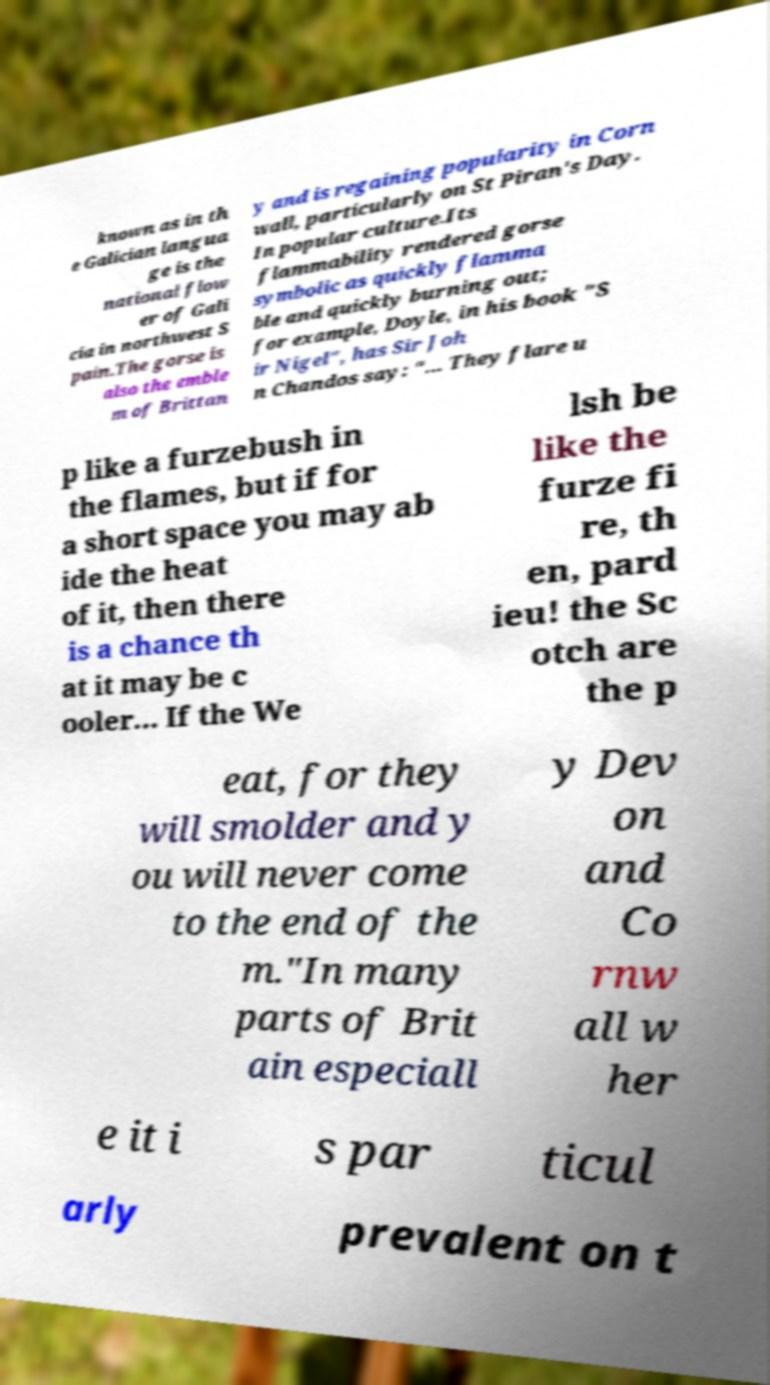For documentation purposes, I need the text within this image transcribed. Could you provide that? known as in th e Galician langua ge is the national flow er of Gali cia in northwest S pain.The gorse is also the emble m of Brittan y and is regaining popularity in Corn wall, particularly on St Piran's Day. In popular culture.Its flammability rendered gorse symbolic as quickly flamma ble and quickly burning out; for example, Doyle, in his book "S ir Nigel", has Sir Joh n Chandos say: "... They flare u p like a furzebush in the flames, but if for a short space you may ab ide the heat of it, then there is a chance th at it may be c ooler... If the We lsh be like the furze fi re, th en, pard ieu! the Sc otch are the p eat, for they will smolder and y ou will never come to the end of the m."In many parts of Brit ain especiall y Dev on and Co rnw all w her e it i s par ticul arly prevalent on t 